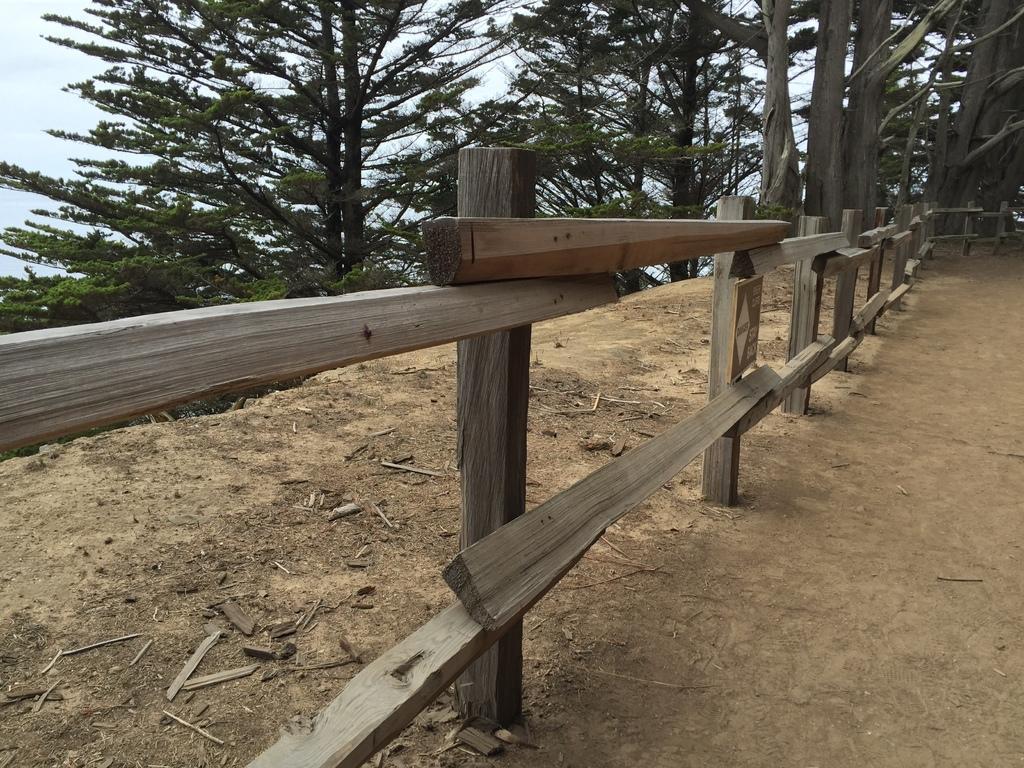How would you summarize this image in a sentence or two? In this picture we can see wooden fence, in the background we can find few trees. 